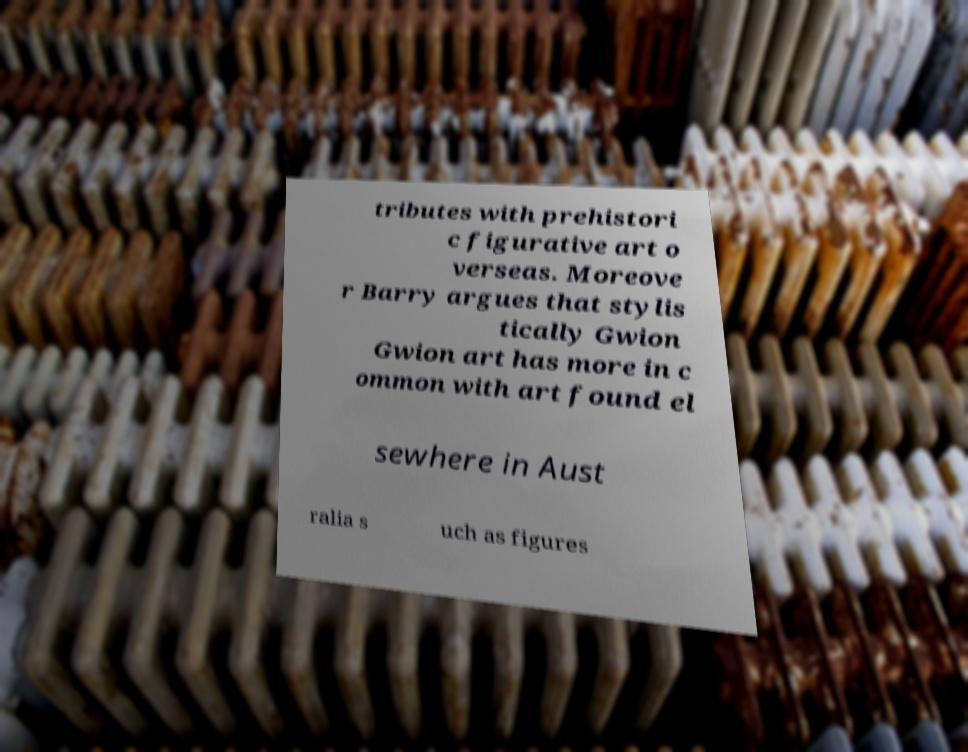Can you read and provide the text displayed in the image?This photo seems to have some interesting text. Can you extract and type it out for me? tributes with prehistori c figurative art o verseas. Moreove r Barry argues that stylis tically Gwion Gwion art has more in c ommon with art found el sewhere in Aust ralia s uch as figures 